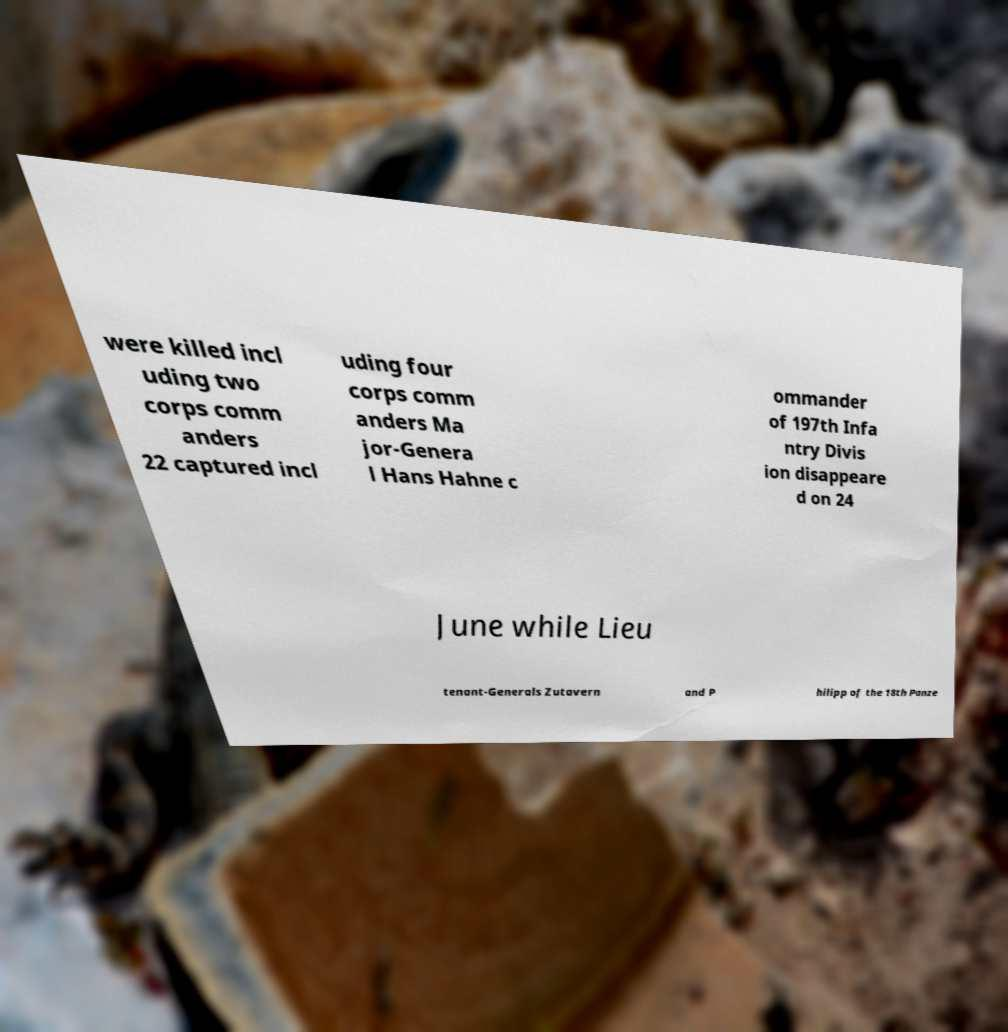I need the written content from this picture converted into text. Can you do that? were killed incl uding two corps comm anders 22 captured incl uding four corps comm anders Ma jor-Genera l Hans Hahne c ommander of 197th Infa ntry Divis ion disappeare d on 24 June while Lieu tenant-Generals Zutavern and P hilipp of the 18th Panze 